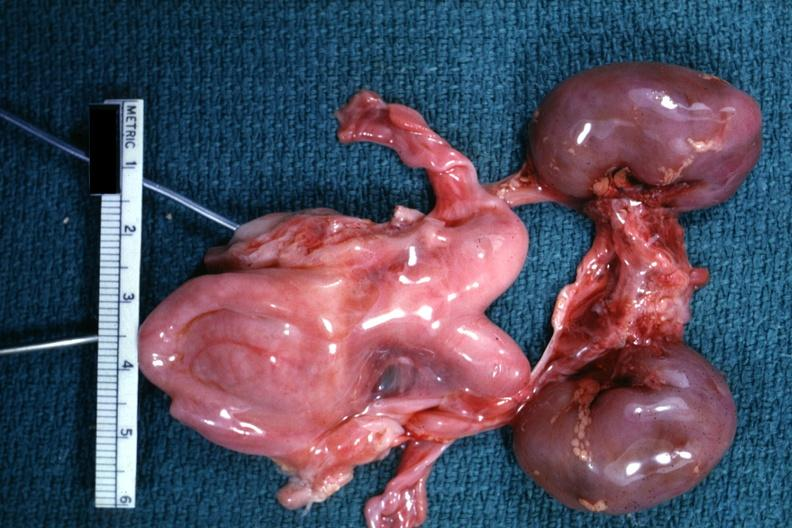what is present?
Answer the question using a single word or phrase. Female reproductive 